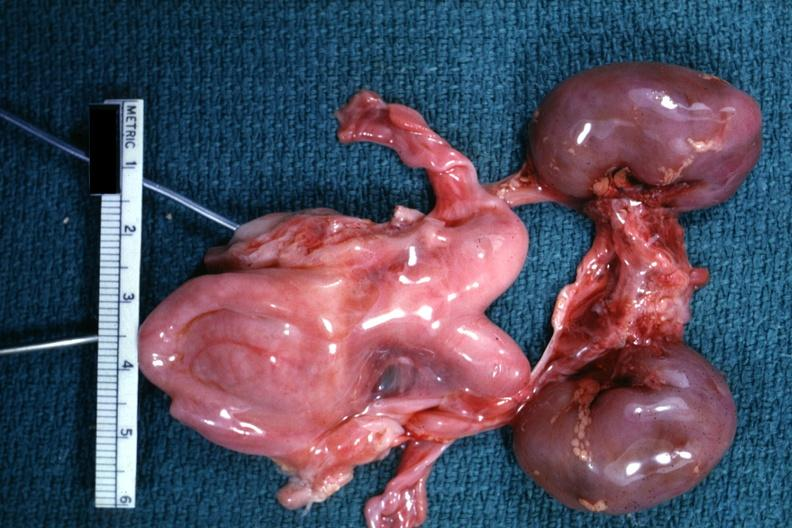what is present?
Answer the question using a single word or phrase. Female reproductive 